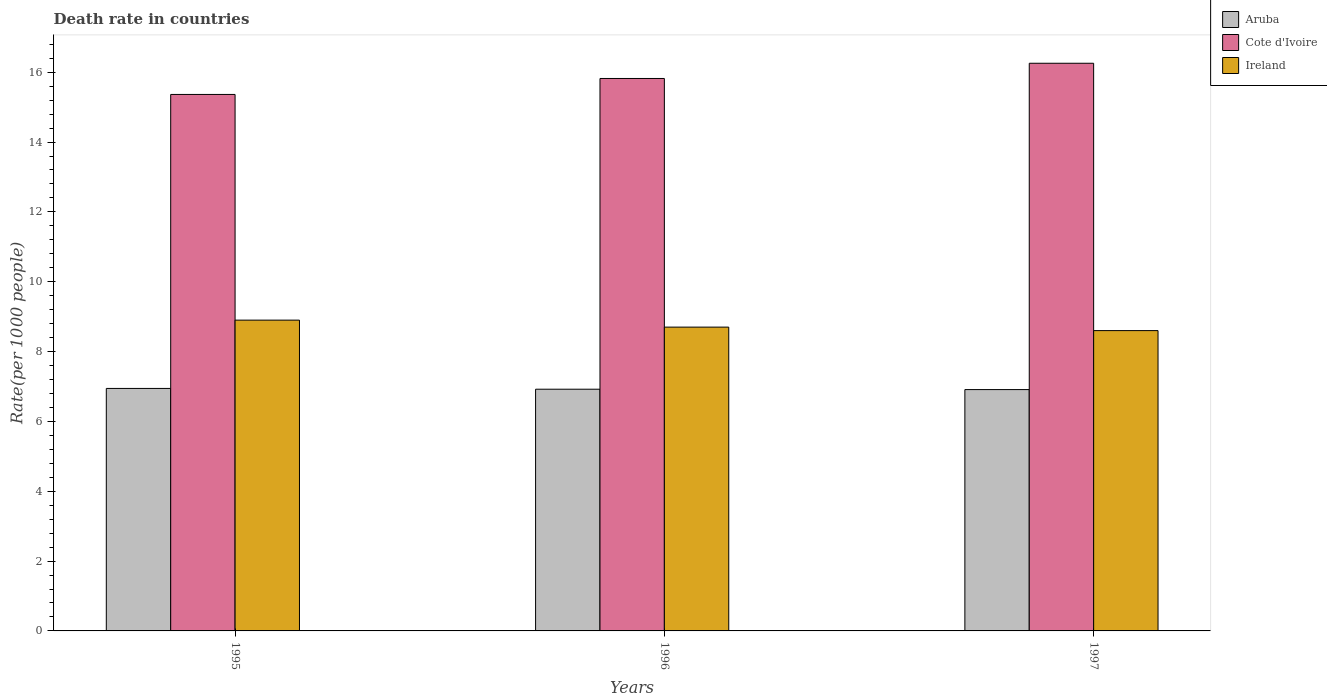How many different coloured bars are there?
Make the answer very short. 3. How many groups of bars are there?
Keep it short and to the point. 3. How many bars are there on the 2nd tick from the left?
Keep it short and to the point. 3. How many bars are there on the 2nd tick from the right?
Offer a terse response. 3. What is the label of the 2nd group of bars from the left?
Offer a very short reply. 1996. In how many cases, is the number of bars for a given year not equal to the number of legend labels?
Keep it short and to the point. 0. What is the death rate in Cote d'Ivoire in 1995?
Offer a very short reply. 15.36. Across all years, what is the maximum death rate in Aruba?
Make the answer very short. 6.94. Across all years, what is the minimum death rate in Ireland?
Offer a terse response. 8.6. In which year was the death rate in Aruba maximum?
Make the answer very short. 1995. What is the total death rate in Aruba in the graph?
Your response must be concise. 20.78. What is the difference between the death rate in Ireland in 1996 and that in 1997?
Give a very brief answer. 0.1. What is the difference between the death rate in Cote d'Ivoire in 1997 and the death rate in Aruba in 1995?
Offer a very short reply. 9.31. What is the average death rate in Ireland per year?
Your answer should be compact. 8.73. In the year 1997, what is the difference between the death rate in Cote d'Ivoire and death rate in Aruba?
Your answer should be very brief. 9.35. What is the ratio of the death rate in Cote d'Ivoire in 1996 to that in 1997?
Offer a terse response. 0.97. What is the difference between the highest and the second highest death rate in Ireland?
Ensure brevity in your answer.  0.2. What is the difference between the highest and the lowest death rate in Aruba?
Your response must be concise. 0.03. What does the 2nd bar from the left in 1996 represents?
Provide a succinct answer. Cote d'Ivoire. What does the 2nd bar from the right in 1997 represents?
Your answer should be very brief. Cote d'Ivoire. Is it the case that in every year, the sum of the death rate in Cote d'Ivoire and death rate in Ireland is greater than the death rate in Aruba?
Ensure brevity in your answer.  Yes. How many bars are there?
Offer a very short reply. 9. How many years are there in the graph?
Give a very brief answer. 3. What is the difference between two consecutive major ticks on the Y-axis?
Your answer should be very brief. 2. Are the values on the major ticks of Y-axis written in scientific E-notation?
Offer a very short reply. No. Does the graph contain any zero values?
Your answer should be very brief. No. Where does the legend appear in the graph?
Provide a succinct answer. Top right. What is the title of the graph?
Make the answer very short. Death rate in countries. Does "Heavily indebted poor countries" appear as one of the legend labels in the graph?
Make the answer very short. No. What is the label or title of the Y-axis?
Your answer should be very brief. Rate(per 1000 people). What is the Rate(per 1000 people) in Aruba in 1995?
Ensure brevity in your answer.  6.94. What is the Rate(per 1000 people) of Cote d'Ivoire in 1995?
Your answer should be very brief. 15.36. What is the Rate(per 1000 people) in Ireland in 1995?
Offer a terse response. 8.9. What is the Rate(per 1000 people) of Aruba in 1996?
Your answer should be very brief. 6.92. What is the Rate(per 1000 people) in Cote d'Ivoire in 1996?
Your response must be concise. 15.82. What is the Rate(per 1000 people) of Aruba in 1997?
Your answer should be compact. 6.91. What is the Rate(per 1000 people) of Cote d'Ivoire in 1997?
Provide a succinct answer. 16.26. Across all years, what is the maximum Rate(per 1000 people) in Aruba?
Provide a short and direct response. 6.94. Across all years, what is the maximum Rate(per 1000 people) in Cote d'Ivoire?
Your answer should be very brief. 16.26. Across all years, what is the minimum Rate(per 1000 people) in Aruba?
Give a very brief answer. 6.91. Across all years, what is the minimum Rate(per 1000 people) of Cote d'Ivoire?
Provide a short and direct response. 15.36. Across all years, what is the minimum Rate(per 1000 people) of Ireland?
Provide a short and direct response. 8.6. What is the total Rate(per 1000 people) of Aruba in the graph?
Provide a short and direct response. 20.78. What is the total Rate(per 1000 people) of Cote d'Ivoire in the graph?
Your response must be concise. 47.44. What is the total Rate(per 1000 people) in Ireland in the graph?
Keep it short and to the point. 26.2. What is the difference between the Rate(per 1000 people) of Aruba in 1995 and that in 1996?
Your response must be concise. 0.02. What is the difference between the Rate(per 1000 people) in Cote d'Ivoire in 1995 and that in 1996?
Offer a very short reply. -0.46. What is the difference between the Rate(per 1000 people) in Aruba in 1995 and that in 1997?
Your answer should be compact. 0.03. What is the difference between the Rate(per 1000 people) in Cote d'Ivoire in 1995 and that in 1997?
Your answer should be compact. -0.89. What is the difference between the Rate(per 1000 people) in Aruba in 1996 and that in 1997?
Keep it short and to the point. 0.01. What is the difference between the Rate(per 1000 people) in Cote d'Ivoire in 1996 and that in 1997?
Offer a very short reply. -0.44. What is the difference between the Rate(per 1000 people) in Aruba in 1995 and the Rate(per 1000 people) in Cote d'Ivoire in 1996?
Offer a very short reply. -8.88. What is the difference between the Rate(per 1000 people) in Aruba in 1995 and the Rate(per 1000 people) in Ireland in 1996?
Your response must be concise. -1.76. What is the difference between the Rate(per 1000 people) in Cote d'Ivoire in 1995 and the Rate(per 1000 people) in Ireland in 1996?
Keep it short and to the point. 6.66. What is the difference between the Rate(per 1000 people) in Aruba in 1995 and the Rate(per 1000 people) in Cote d'Ivoire in 1997?
Keep it short and to the point. -9.31. What is the difference between the Rate(per 1000 people) in Aruba in 1995 and the Rate(per 1000 people) in Ireland in 1997?
Keep it short and to the point. -1.66. What is the difference between the Rate(per 1000 people) of Cote d'Ivoire in 1995 and the Rate(per 1000 people) of Ireland in 1997?
Your response must be concise. 6.76. What is the difference between the Rate(per 1000 people) in Aruba in 1996 and the Rate(per 1000 people) in Cote d'Ivoire in 1997?
Your answer should be compact. -9.33. What is the difference between the Rate(per 1000 people) of Aruba in 1996 and the Rate(per 1000 people) of Ireland in 1997?
Your answer should be compact. -1.68. What is the difference between the Rate(per 1000 people) of Cote d'Ivoire in 1996 and the Rate(per 1000 people) of Ireland in 1997?
Make the answer very short. 7.22. What is the average Rate(per 1000 people) of Aruba per year?
Make the answer very short. 6.93. What is the average Rate(per 1000 people) of Cote d'Ivoire per year?
Your answer should be very brief. 15.81. What is the average Rate(per 1000 people) of Ireland per year?
Offer a very short reply. 8.73. In the year 1995, what is the difference between the Rate(per 1000 people) in Aruba and Rate(per 1000 people) in Cote d'Ivoire?
Make the answer very short. -8.42. In the year 1995, what is the difference between the Rate(per 1000 people) of Aruba and Rate(per 1000 people) of Ireland?
Ensure brevity in your answer.  -1.96. In the year 1995, what is the difference between the Rate(per 1000 people) of Cote d'Ivoire and Rate(per 1000 people) of Ireland?
Keep it short and to the point. 6.46. In the year 1996, what is the difference between the Rate(per 1000 people) in Aruba and Rate(per 1000 people) in Cote d'Ivoire?
Give a very brief answer. -8.9. In the year 1996, what is the difference between the Rate(per 1000 people) in Aruba and Rate(per 1000 people) in Ireland?
Your answer should be compact. -1.78. In the year 1996, what is the difference between the Rate(per 1000 people) of Cote d'Ivoire and Rate(per 1000 people) of Ireland?
Give a very brief answer. 7.12. In the year 1997, what is the difference between the Rate(per 1000 people) of Aruba and Rate(per 1000 people) of Cote d'Ivoire?
Keep it short and to the point. -9.35. In the year 1997, what is the difference between the Rate(per 1000 people) in Aruba and Rate(per 1000 people) in Ireland?
Make the answer very short. -1.69. In the year 1997, what is the difference between the Rate(per 1000 people) in Cote d'Ivoire and Rate(per 1000 people) in Ireland?
Ensure brevity in your answer.  7.66. What is the ratio of the Rate(per 1000 people) of Cote d'Ivoire in 1995 to that in 1996?
Offer a terse response. 0.97. What is the ratio of the Rate(per 1000 people) in Ireland in 1995 to that in 1996?
Make the answer very short. 1.02. What is the ratio of the Rate(per 1000 people) in Cote d'Ivoire in 1995 to that in 1997?
Make the answer very short. 0.95. What is the ratio of the Rate(per 1000 people) of Ireland in 1995 to that in 1997?
Your response must be concise. 1.03. What is the ratio of the Rate(per 1000 people) of Cote d'Ivoire in 1996 to that in 1997?
Keep it short and to the point. 0.97. What is the ratio of the Rate(per 1000 people) of Ireland in 1996 to that in 1997?
Your answer should be compact. 1.01. What is the difference between the highest and the second highest Rate(per 1000 people) of Aruba?
Your answer should be very brief. 0.02. What is the difference between the highest and the second highest Rate(per 1000 people) in Cote d'Ivoire?
Give a very brief answer. 0.44. What is the difference between the highest and the lowest Rate(per 1000 people) in Aruba?
Your answer should be very brief. 0.03. What is the difference between the highest and the lowest Rate(per 1000 people) in Cote d'Ivoire?
Make the answer very short. 0.89. 